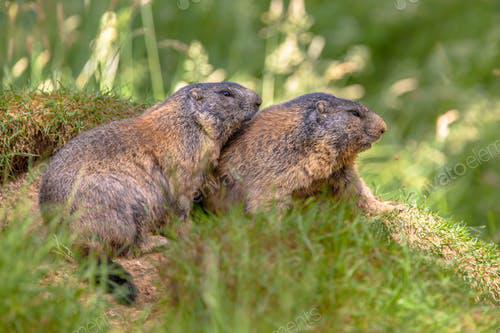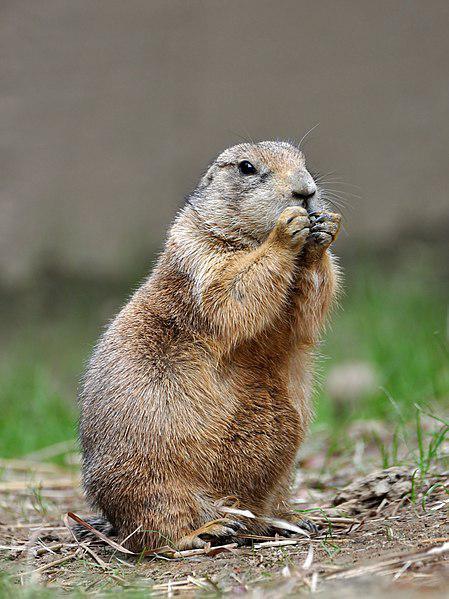The first image is the image on the left, the second image is the image on the right. Examine the images to the left and right. Is the description "A young boy is next to at least one groundhog." accurate? Answer yes or no. No. The first image is the image on the left, the second image is the image on the right. Assess this claim about the two images: "In one image there is a boy next to at least one marmot.". Correct or not? Answer yes or no. No. 